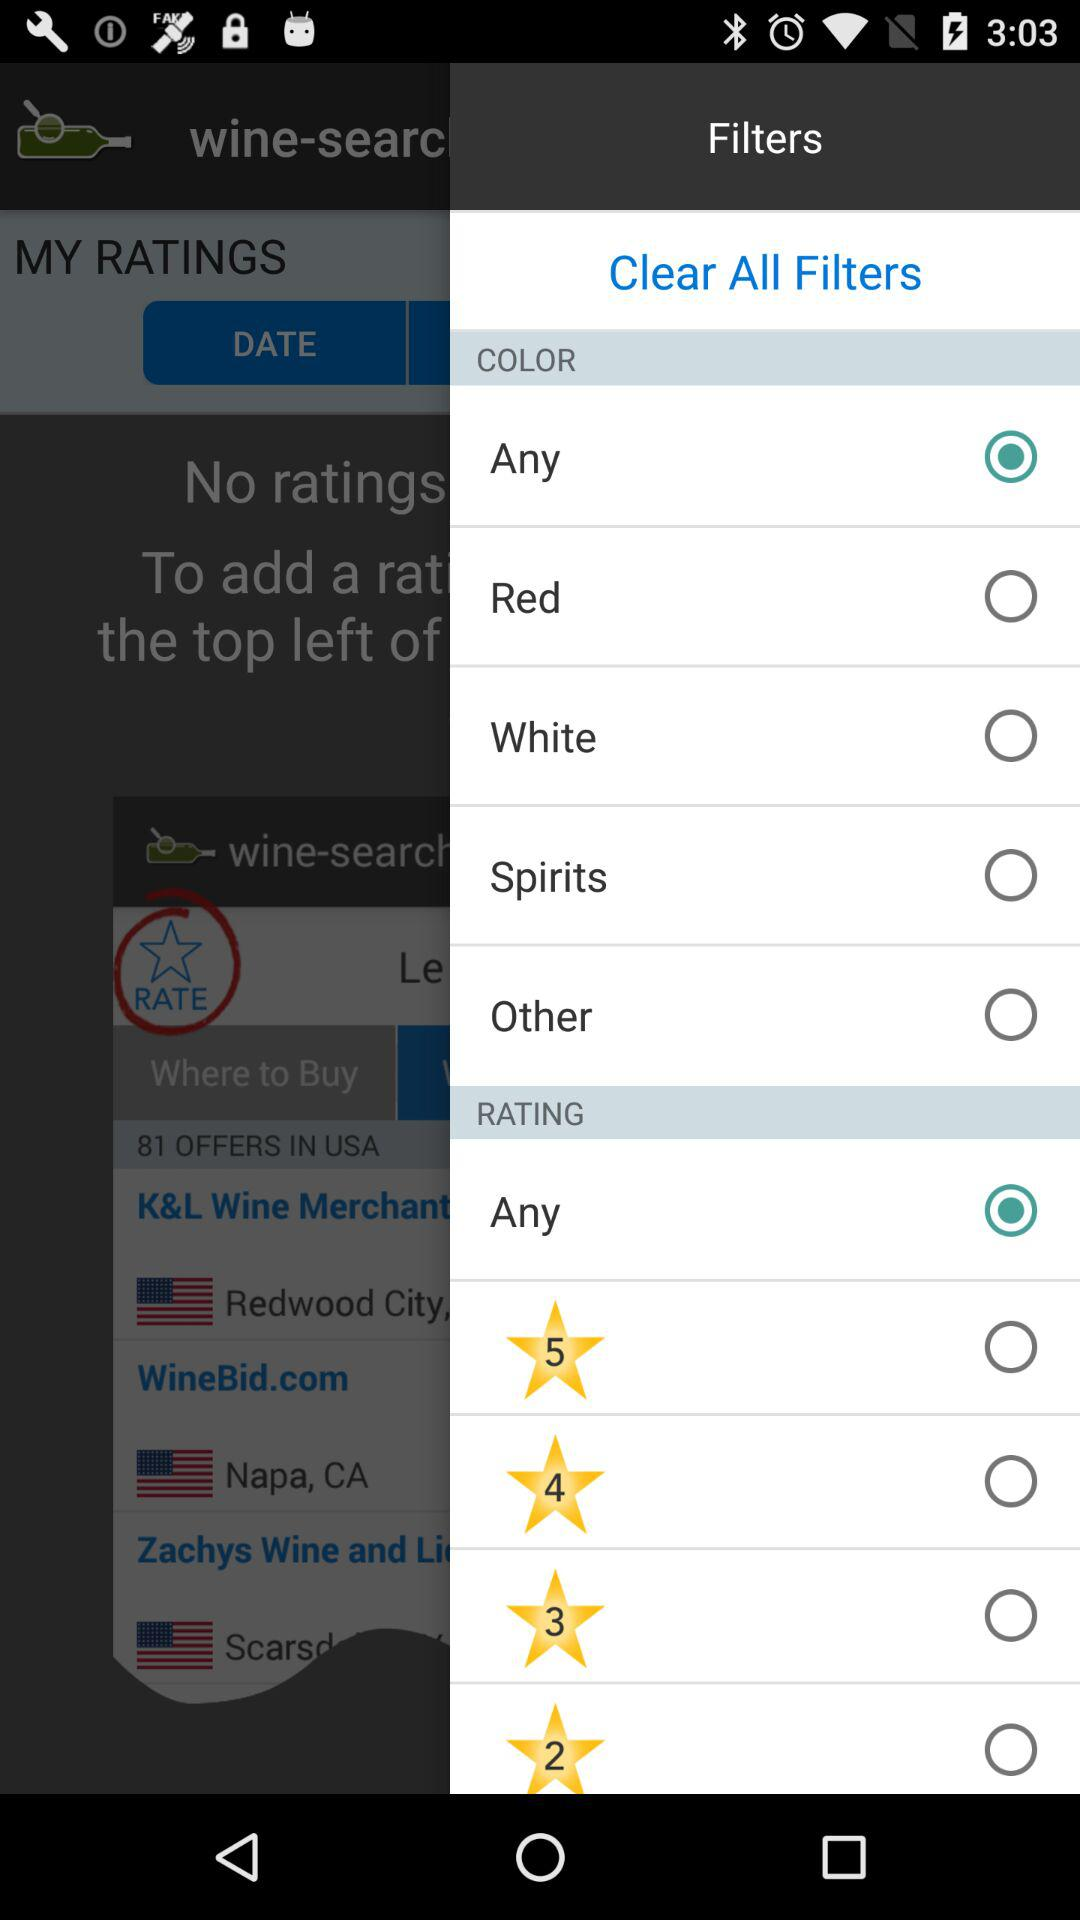How many rating options are available?
Answer the question using a single word or phrase. 5 